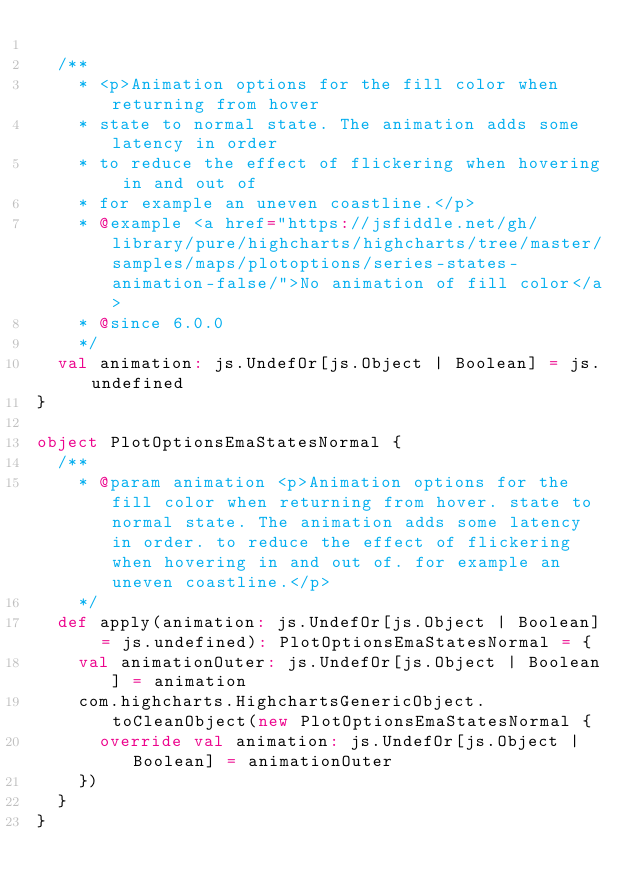<code> <loc_0><loc_0><loc_500><loc_500><_Scala_>
  /**
    * <p>Animation options for the fill color when returning from hover
    * state to normal state. The animation adds some latency in order
    * to reduce the effect of flickering when hovering in and out of
    * for example an uneven coastline.</p>
    * @example <a href="https://jsfiddle.net/gh/library/pure/highcharts/highcharts/tree/master/samples/maps/plotoptions/series-states-animation-false/">No animation of fill color</a>
    * @since 6.0.0
    */
  val animation: js.UndefOr[js.Object | Boolean] = js.undefined
}

object PlotOptionsEmaStatesNormal {
  /**
    * @param animation <p>Animation options for the fill color when returning from hover. state to normal state. The animation adds some latency in order. to reduce the effect of flickering when hovering in and out of. for example an uneven coastline.</p>
    */
  def apply(animation: js.UndefOr[js.Object | Boolean] = js.undefined): PlotOptionsEmaStatesNormal = {
    val animationOuter: js.UndefOr[js.Object | Boolean] = animation
    com.highcharts.HighchartsGenericObject.toCleanObject(new PlotOptionsEmaStatesNormal {
      override val animation: js.UndefOr[js.Object | Boolean] = animationOuter
    })
  }
}
</code> 